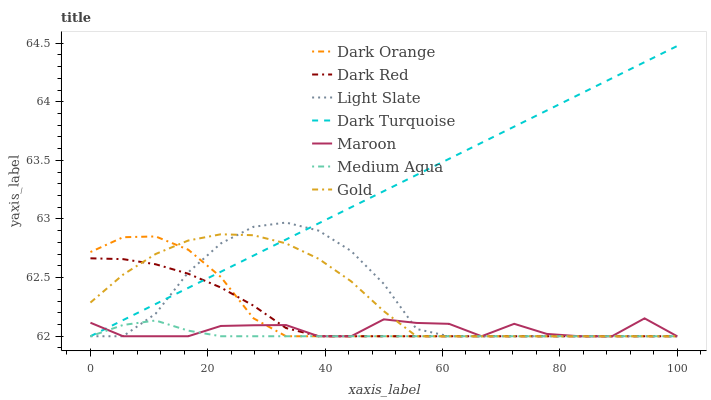Does Medium Aqua have the minimum area under the curve?
Answer yes or no. Yes. Does Dark Turquoise have the maximum area under the curve?
Answer yes or no. Yes. Does Gold have the minimum area under the curve?
Answer yes or no. No. Does Gold have the maximum area under the curve?
Answer yes or no. No. Is Dark Turquoise the smoothest?
Answer yes or no. Yes. Is Maroon the roughest?
Answer yes or no. Yes. Is Gold the smoothest?
Answer yes or no. No. Is Gold the roughest?
Answer yes or no. No. Does Dark Orange have the lowest value?
Answer yes or no. Yes. Does Dark Turquoise have the highest value?
Answer yes or no. Yes. Does Gold have the highest value?
Answer yes or no. No. Does Dark Red intersect Medium Aqua?
Answer yes or no. Yes. Is Dark Red less than Medium Aqua?
Answer yes or no. No. Is Dark Red greater than Medium Aqua?
Answer yes or no. No. 